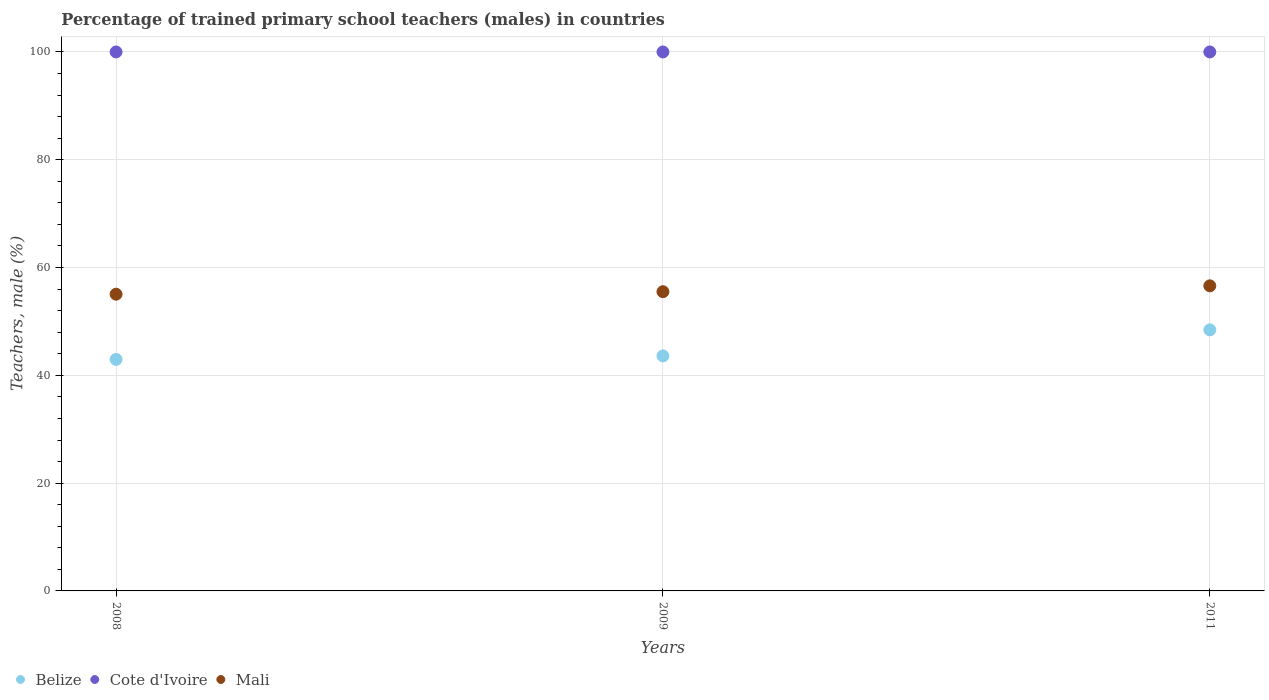How many different coloured dotlines are there?
Offer a very short reply. 3. Is the number of dotlines equal to the number of legend labels?
Give a very brief answer. Yes. Across all years, what is the maximum percentage of trained primary school teachers (males) in Cote d'Ivoire?
Ensure brevity in your answer.  100. Across all years, what is the minimum percentage of trained primary school teachers (males) in Belize?
Keep it short and to the point. 42.95. What is the total percentage of trained primary school teachers (males) in Mali in the graph?
Your response must be concise. 167.18. What is the difference between the percentage of trained primary school teachers (males) in Belize in 2008 and that in 2009?
Provide a short and direct response. -0.65. What is the difference between the percentage of trained primary school teachers (males) in Mali in 2011 and the percentage of trained primary school teachers (males) in Cote d'Ivoire in 2009?
Your answer should be compact. -43.39. What is the average percentage of trained primary school teachers (males) in Cote d'Ivoire per year?
Provide a succinct answer. 100. In the year 2008, what is the difference between the percentage of trained primary school teachers (males) in Cote d'Ivoire and percentage of trained primary school teachers (males) in Belize?
Your answer should be very brief. 57.05. In how many years, is the percentage of trained primary school teachers (males) in Mali greater than 40 %?
Make the answer very short. 3. What is the ratio of the percentage of trained primary school teachers (males) in Belize in 2008 to that in 2011?
Provide a succinct answer. 0.89. Is the percentage of trained primary school teachers (males) in Cote d'Ivoire in 2008 less than that in 2011?
Your answer should be compact. No. Is the difference between the percentage of trained primary school teachers (males) in Cote d'Ivoire in 2009 and 2011 greater than the difference between the percentage of trained primary school teachers (males) in Belize in 2009 and 2011?
Give a very brief answer. Yes. What is the difference between the highest and the second highest percentage of trained primary school teachers (males) in Mali?
Provide a succinct answer. 1.09. What is the difference between the highest and the lowest percentage of trained primary school teachers (males) in Belize?
Keep it short and to the point. 5.49. In how many years, is the percentage of trained primary school teachers (males) in Belize greater than the average percentage of trained primary school teachers (males) in Belize taken over all years?
Your response must be concise. 1. Is the sum of the percentage of trained primary school teachers (males) in Belize in 2008 and 2009 greater than the maximum percentage of trained primary school teachers (males) in Cote d'Ivoire across all years?
Offer a terse response. No. Is it the case that in every year, the sum of the percentage of trained primary school teachers (males) in Cote d'Ivoire and percentage of trained primary school teachers (males) in Belize  is greater than the percentage of trained primary school teachers (males) in Mali?
Offer a very short reply. Yes. Is the percentage of trained primary school teachers (males) in Cote d'Ivoire strictly less than the percentage of trained primary school teachers (males) in Belize over the years?
Provide a succinct answer. No. How many dotlines are there?
Your answer should be compact. 3. How many years are there in the graph?
Your answer should be very brief. 3. Are the values on the major ticks of Y-axis written in scientific E-notation?
Your answer should be very brief. No. How are the legend labels stacked?
Make the answer very short. Horizontal. What is the title of the graph?
Provide a succinct answer. Percentage of trained primary school teachers (males) in countries. What is the label or title of the Y-axis?
Keep it short and to the point. Teachers, male (%). What is the Teachers, male (%) of Belize in 2008?
Ensure brevity in your answer.  42.95. What is the Teachers, male (%) of Mali in 2008?
Keep it short and to the point. 55.05. What is the Teachers, male (%) of Belize in 2009?
Your answer should be compact. 43.6. What is the Teachers, male (%) in Cote d'Ivoire in 2009?
Offer a very short reply. 100. What is the Teachers, male (%) in Mali in 2009?
Ensure brevity in your answer.  55.52. What is the Teachers, male (%) of Belize in 2011?
Ensure brevity in your answer.  48.44. What is the Teachers, male (%) in Cote d'Ivoire in 2011?
Offer a terse response. 100. What is the Teachers, male (%) of Mali in 2011?
Make the answer very short. 56.61. Across all years, what is the maximum Teachers, male (%) of Belize?
Make the answer very short. 48.44. Across all years, what is the maximum Teachers, male (%) in Cote d'Ivoire?
Provide a succinct answer. 100. Across all years, what is the maximum Teachers, male (%) of Mali?
Provide a succinct answer. 56.61. Across all years, what is the minimum Teachers, male (%) in Belize?
Your answer should be compact. 42.95. Across all years, what is the minimum Teachers, male (%) in Mali?
Your answer should be very brief. 55.05. What is the total Teachers, male (%) in Belize in the graph?
Your answer should be very brief. 135. What is the total Teachers, male (%) in Cote d'Ivoire in the graph?
Offer a very short reply. 300. What is the total Teachers, male (%) of Mali in the graph?
Provide a succinct answer. 167.18. What is the difference between the Teachers, male (%) of Belize in 2008 and that in 2009?
Your answer should be very brief. -0.65. What is the difference between the Teachers, male (%) of Cote d'Ivoire in 2008 and that in 2009?
Your answer should be very brief. 0. What is the difference between the Teachers, male (%) of Mali in 2008 and that in 2009?
Provide a succinct answer. -0.46. What is the difference between the Teachers, male (%) in Belize in 2008 and that in 2011?
Your answer should be compact. -5.49. What is the difference between the Teachers, male (%) of Cote d'Ivoire in 2008 and that in 2011?
Provide a succinct answer. 0. What is the difference between the Teachers, male (%) of Mali in 2008 and that in 2011?
Your answer should be very brief. -1.55. What is the difference between the Teachers, male (%) in Belize in 2009 and that in 2011?
Keep it short and to the point. -4.84. What is the difference between the Teachers, male (%) of Cote d'Ivoire in 2009 and that in 2011?
Make the answer very short. 0. What is the difference between the Teachers, male (%) in Mali in 2009 and that in 2011?
Make the answer very short. -1.09. What is the difference between the Teachers, male (%) of Belize in 2008 and the Teachers, male (%) of Cote d'Ivoire in 2009?
Your answer should be very brief. -57.05. What is the difference between the Teachers, male (%) in Belize in 2008 and the Teachers, male (%) in Mali in 2009?
Offer a very short reply. -12.56. What is the difference between the Teachers, male (%) in Cote d'Ivoire in 2008 and the Teachers, male (%) in Mali in 2009?
Your response must be concise. 44.48. What is the difference between the Teachers, male (%) in Belize in 2008 and the Teachers, male (%) in Cote d'Ivoire in 2011?
Your answer should be compact. -57.05. What is the difference between the Teachers, male (%) in Belize in 2008 and the Teachers, male (%) in Mali in 2011?
Provide a short and direct response. -13.65. What is the difference between the Teachers, male (%) in Cote d'Ivoire in 2008 and the Teachers, male (%) in Mali in 2011?
Provide a succinct answer. 43.39. What is the difference between the Teachers, male (%) of Belize in 2009 and the Teachers, male (%) of Cote d'Ivoire in 2011?
Ensure brevity in your answer.  -56.4. What is the difference between the Teachers, male (%) in Belize in 2009 and the Teachers, male (%) in Mali in 2011?
Your response must be concise. -13. What is the difference between the Teachers, male (%) of Cote d'Ivoire in 2009 and the Teachers, male (%) of Mali in 2011?
Your response must be concise. 43.39. What is the average Teachers, male (%) in Belize per year?
Ensure brevity in your answer.  45. What is the average Teachers, male (%) of Cote d'Ivoire per year?
Give a very brief answer. 100. What is the average Teachers, male (%) of Mali per year?
Your answer should be compact. 55.73. In the year 2008, what is the difference between the Teachers, male (%) in Belize and Teachers, male (%) in Cote d'Ivoire?
Your answer should be very brief. -57.05. In the year 2008, what is the difference between the Teachers, male (%) of Belize and Teachers, male (%) of Mali?
Give a very brief answer. -12.1. In the year 2008, what is the difference between the Teachers, male (%) in Cote d'Ivoire and Teachers, male (%) in Mali?
Your answer should be very brief. 44.95. In the year 2009, what is the difference between the Teachers, male (%) in Belize and Teachers, male (%) in Cote d'Ivoire?
Provide a short and direct response. -56.4. In the year 2009, what is the difference between the Teachers, male (%) of Belize and Teachers, male (%) of Mali?
Keep it short and to the point. -11.91. In the year 2009, what is the difference between the Teachers, male (%) of Cote d'Ivoire and Teachers, male (%) of Mali?
Offer a very short reply. 44.48. In the year 2011, what is the difference between the Teachers, male (%) of Belize and Teachers, male (%) of Cote d'Ivoire?
Keep it short and to the point. -51.56. In the year 2011, what is the difference between the Teachers, male (%) of Belize and Teachers, male (%) of Mali?
Make the answer very short. -8.16. In the year 2011, what is the difference between the Teachers, male (%) in Cote d'Ivoire and Teachers, male (%) in Mali?
Provide a short and direct response. 43.39. What is the ratio of the Teachers, male (%) of Mali in 2008 to that in 2009?
Your answer should be compact. 0.99. What is the ratio of the Teachers, male (%) in Belize in 2008 to that in 2011?
Offer a very short reply. 0.89. What is the ratio of the Teachers, male (%) in Mali in 2008 to that in 2011?
Give a very brief answer. 0.97. What is the ratio of the Teachers, male (%) in Belize in 2009 to that in 2011?
Keep it short and to the point. 0.9. What is the ratio of the Teachers, male (%) of Mali in 2009 to that in 2011?
Keep it short and to the point. 0.98. What is the difference between the highest and the second highest Teachers, male (%) of Belize?
Keep it short and to the point. 4.84. What is the difference between the highest and the second highest Teachers, male (%) of Cote d'Ivoire?
Your response must be concise. 0. What is the difference between the highest and the second highest Teachers, male (%) in Mali?
Offer a terse response. 1.09. What is the difference between the highest and the lowest Teachers, male (%) in Belize?
Make the answer very short. 5.49. What is the difference between the highest and the lowest Teachers, male (%) in Cote d'Ivoire?
Offer a very short reply. 0. What is the difference between the highest and the lowest Teachers, male (%) in Mali?
Your answer should be very brief. 1.55. 